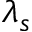<formula> <loc_0><loc_0><loc_500><loc_500>\lambda _ { s }</formula> 